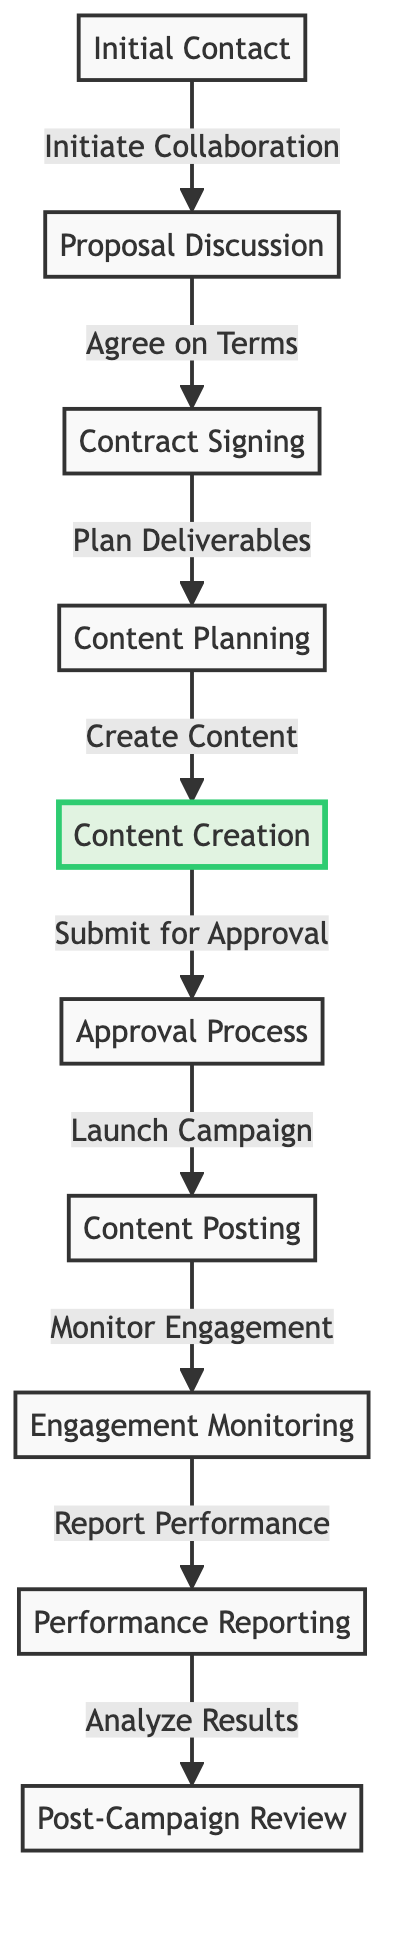What is the first step in the campaign timeline? The diagram indicates that the first step, or initial node, in the campaign timeline is "Initial Contact." This is represented as node 1 in the flowchart.
Answer: Initial Contact How many total steps are there in the campaign timeline? By counting the nodes in the diagram, we can see that there are ten distinct steps, from "Initial Contact" to "Post-Campaign Review."
Answer: 10 Which node follows the "Content Planning" step? In the diagram, the node that directly follows "Content Planning" (node 4) is "Content Creation" (node 5). This can be found by following the arrow from node 4 to node 5.
Answer: Content Creation What action is associated with the transition from "Approval Process" to "Content Posting"? The diagram specifies the action associated with the transition between these two nodes as "Launch Campaign." This action connects node 6 ("Approval Process") to node 7 ("Content Posting").
Answer: Launch Campaign Which step involves monitoring engagement after the content has been posted? The diagram shows that the step for monitoring engagement after the content post is called "Engagement Monitoring," which is node 8 in the timeline.
Answer: Engagement Monitoring What is the last step of the campaign timeline? The final step in the campaign timeline is "Post-Campaign Review," which is represented as node 10 in the diagram. This conclusion can be determined by looking for the last node in the flowchart sequence.
Answer: Post-Campaign Review What are the two main actions detailed before "Content Creation"? According to the diagram, the two main actions that precede "Content Creation" (node 5) are "Plan Deliverables" (node 3) and "Content Planning" (node 4). This requires tracing back through the nodes leading to node 5.
Answer: Plan Deliverables, Content Planning Which stage involves submitting content for approval? The diagram specifies that the stage involving submission for approval is "Submit for Approval," corresponding with node 6 in the flowchart.
Answer: Submit for Approval Which stage comes immediately after the content has been created? In the flowchart, the stage that follows "Content Creation" (node 5) is "Approval Process" (node 6). This is evident by the direct connection from node 5 to node 6.
Answer: Approval Process 